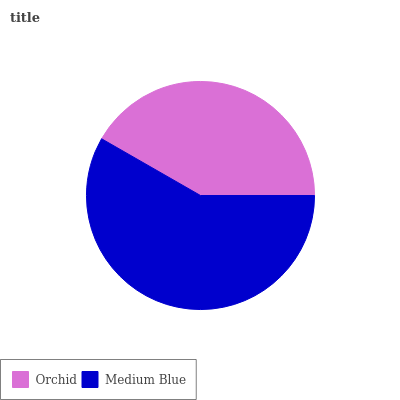Is Orchid the minimum?
Answer yes or no. Yes. Is Medium Blue the maximum?
Answer yes or no. Yes. Is Medium Blue the minimum?
Answer yes or no. No. Is Medium Blue greater than Orchid?
Answer yes or no. Yes. Is Orchid less than Medium Blue?
Answer yes or no. Yes. Is Orchid greater than Medium Blue?
Answer yes or no. No. Is Medium Blue less than Orchid?
Answer yes or no. No. Is Medium Blue the high median?
Answer yes or no. Yes. Is Orchid the low median?
Answer yes or no. Yes. Is Orchid the high median?
Answer yes or no. No. Is Medium Blue the low median?
Answer yes or no. No. 